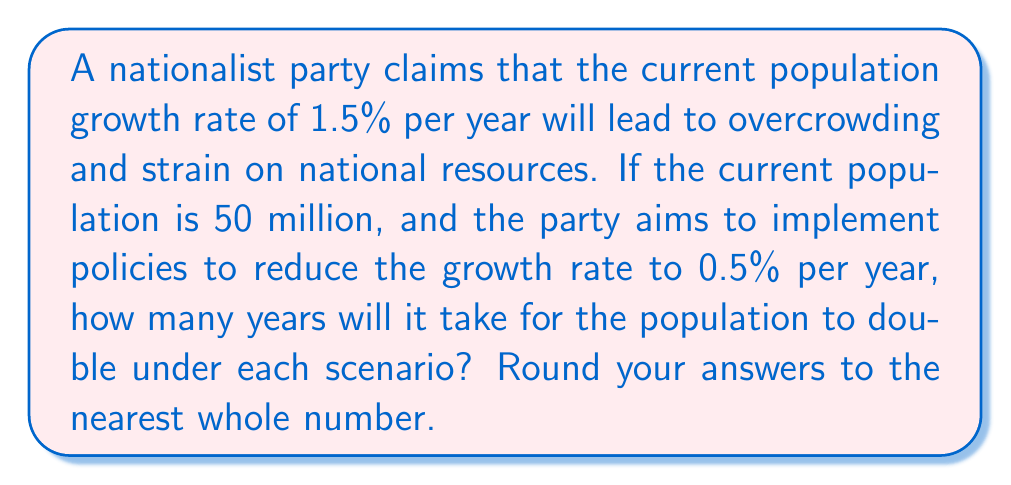Could you help me with this problem? To solve this problem, we'll use the doubling time formula derived from exponential growth models:

$$T = \frac{\ln(2)}{r}$$

Where $T$ is the doubling time in years, and $r$ is the growth rate as a decimal.

1. For the current growth rate of 1.5% (0.015):
   $$T_1 = \frac{\ln(2)}{0.015} \approx 46.2$$

2. For the proposed reduced growth rate of 0.5% (0.005):
   $$T_2 = \frac{\ln(2)}{0.005} \approx 138.6$$

Rounding to the nearest whole number:
Current growth rate: 46 years
Reduced growth rate: 139 years

The difference in doubling time is 139 - 46 = 93 years.
Answer: 46 years (current rate), 139 years (reduced rate) 